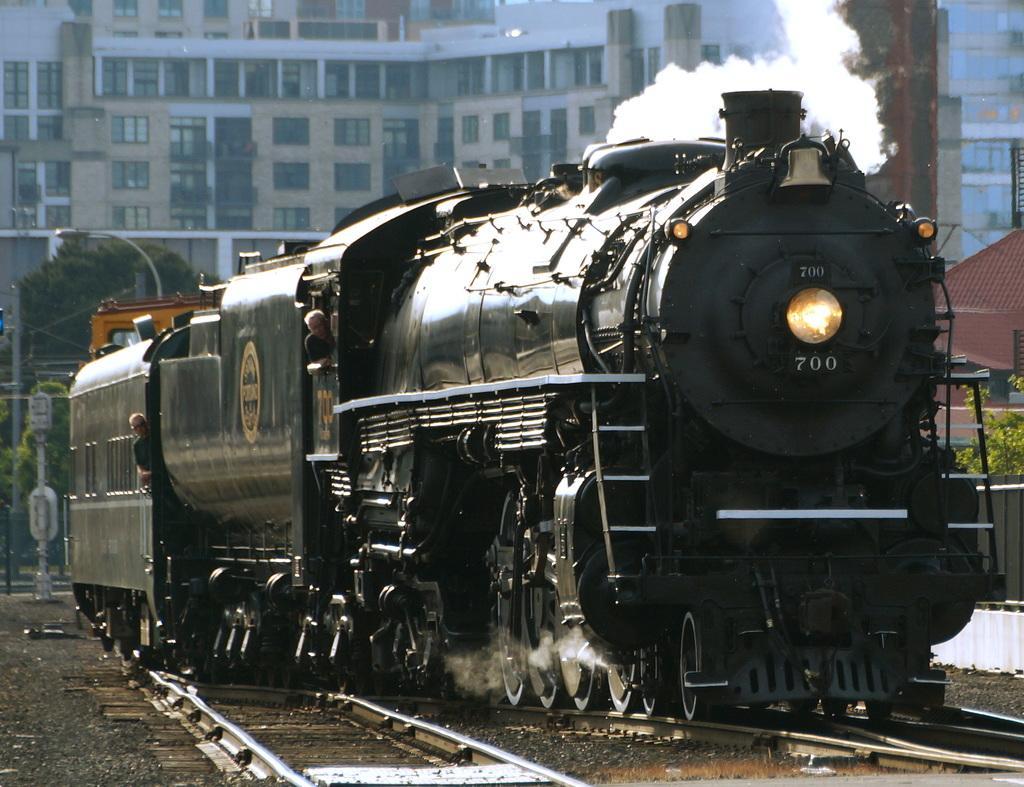How would you summarize this image in a sentence or two? In this image, we can see the train. We can see some railway tracks, buildings, plants, poles. We can see a person and a tree. We can see some objects on the left. We can also see some smoke. We can see the ground with some objects. 